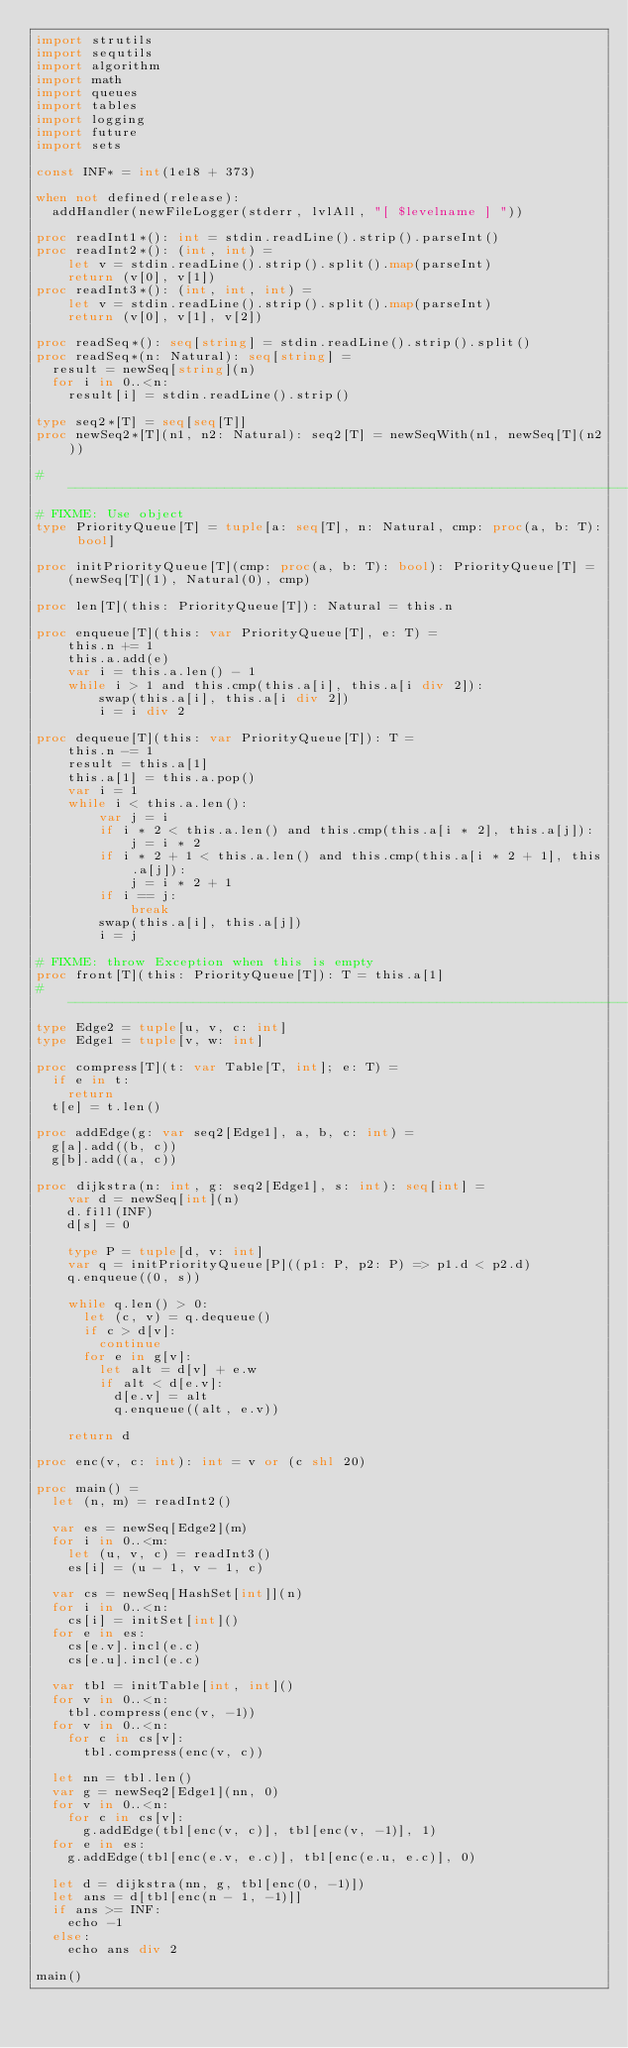Convert code to text. <code><loc_0><loc_0><loc_500><loc_500><_Nim_>import strutils
import sequtils
import algorithm
import math
import queues
import tables
import logging
import future
import sets

const INF* = int(1e18 + 373)

when not defined(release):
  addHandler(newFileLogger(stderr, lvlAll, "[ $levelname ] "))

proc readInt1*(): int = stdin.readLine().strip().parseInt()
proc readInt2*(): (int, int) =
    let v = stdin.readLine().strip().split().map(parseInt)
    return (v[0], v[1])
proc readInt3*(): (int, int, int) =
    let v = stdin.readLine().strip().split().map(parseInt)
    return (v[0], v[1], v[2])

proc readSeq*(): seq[string] = stdin.readLine().strip().split()
proc readSeq*(n: Natural): seq[string] =
  result = newSeq[string](n)
  for i in 0..<n:
    result[i] = stdin.readLine().strip()

type seq2*[T] = seq[seq[T]]
proc newSeq2*[T](n1, n2: Natural): seq2[T] = newSeqWith(n1, newSeq[T](n2))

#------------------------------------------------------------------------------#
# FIXME: Use object
type PriorityQueue[T] = tuple[a: seq[T], n: Natural, cmp: proc(a, b: T): bool]

proc initPriorityQueue[T](cmp: proc(a, b: T): bool): PriorityQueue[T] =
    (newSeq[T](1), Natural(0), cmp)

proc len[T](this: PriorityQueue[T]): Natural = this.n

proc enqueue[T](this: var PriorityQueue[T], e: T) =
    this.n += 1
    this.a.add(e)
    var i = this.a.len() - 1
    while i > 1 and this.cmp(this.a[i], this.a[i div 2]):
        swap(this.a[i], this.a[i div 2])
        i = i div 2

proc dequeue[T](this: var PriorityQueue[T]): T =
    this.n -= 1
    result = this.a[1]
    this.a[1] = this.a.pop()
    var i = 1
    while i < this.a.len():
        var j = i
        if i * 2 < this.a.len() and this.cmp(this.a[i * 2], this.a[j]):
            j = i * 2
        if i * 2 + 1 < this.a.len() and this.cmp(this.a[i * 2 + 1], this.a[j]):
            j = i * 2 + 1
        if i == j:
            break
        swap(this.a[i], this.a[j])
        i = j

# FIXME: throw Exception when this is empty
proc front[T](this: PriorityQueue[T]): T = this.a[1]
#------------------------------------------------------------------------------#
type Edge2 = tuple[u, v, c: int]
type Edge1 = tuple[v, w: int]

proc compress[T](t: var Table[T, int]; e: T) =
  if e in t:
    return
  t[e] = t.len()

proc addEdge(g: var seq2[Edge1], a, b, c: int) =
  g[a].add((b, c))
  g[b].add((a, c))

proc dijkstra(n: int, g: seq2[Edge1], s: int): seq[int] =
    var d = newSeq[int](n)
    d.fill(INF)
    d[s] = 0

    type P = tuple[d, v: int]
    var q = initPriorityQueue[P]((p1: P, p2: P) => p1.d < p2.d)
    q.enqueue((0, s))

    while q.len() > 0:
      let (c, v) = q.dequeue()
      if c > d[v]:
        continue
      for e in g[v]:
        let alt = d[v] + e.w
        if alt < d[e.v]:
          d[e.v] = alt
          q.enqueue((alt, e.v))

    return d

proc enc(v, c: int): int = v or (c shl 20)

proc main() =
  let (n, m) = readInt2()

  var es = newSeq[Edge2](m)
  for i in 0..<m:
    let (u, v, c) = readInt3()
    es[i] = (u - 1, v - 1, c)

  var cs = newSeq[HashSet[int]](n)
  for i in 0..<n:
    cs[i] = initSet[int]()
  for e in es:
    cs[e.v].incl(e.c)
    cs[e.u].incl(e.c)

  var tbl = initTable[int, int]()
  for v in 0..<n:
    tbl.compress(enc(v, -1))
  for v in 0..<n:
    for c in cs[v]:
      tbl.compress(enc(v, c))

  let nn = tbl.len()
  var g = newSeq2[Edge1](nn, 0)
  for v in 0..<n:
    for c in cs[v]:
      g.addEdge(tbl[enc(v, c)], tbl[enc(v, -1)], 1)
  for e in es:
    g.addEdge(tbl[enc(e.v, e.c)], tbl[enc(e.u, e.c)], 0)

  let d = dijkstra(nn, g, tbl[enc(0, -1)])
  let ans = d[tbl[enc(n - 1, -1)]]
  if ans >= INF:
    echo -1
  else:
    echo ans div 2

main()

</code> 